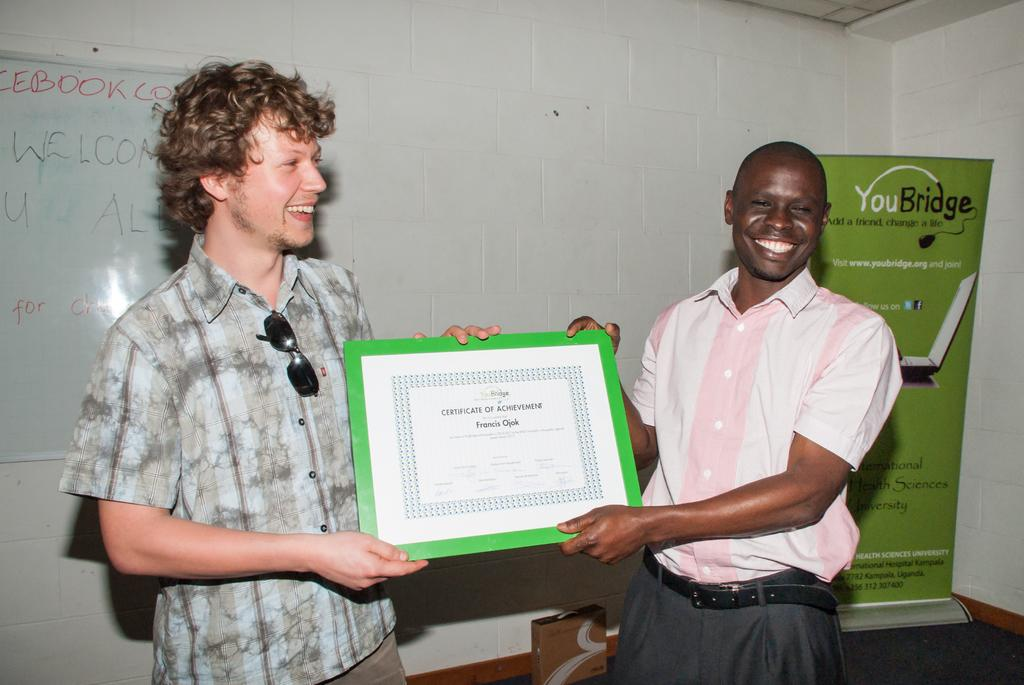How many people are present in the image? There are two people standing in the image. What are the two people holding? The two people are holding a frame. Can you describe the color of the frame? The frame is green and white in color. What other green elements can be seen in the image? There is a green color board visible in the image. What color is the wall behind the people? There is a white wall visible in the image. What type of skirt can be seen on the hill in the image? There is no skirt or hill present in the image. How many cushions are visible on the green color board in the image? There are no cushions visible on the green color board in the image. 